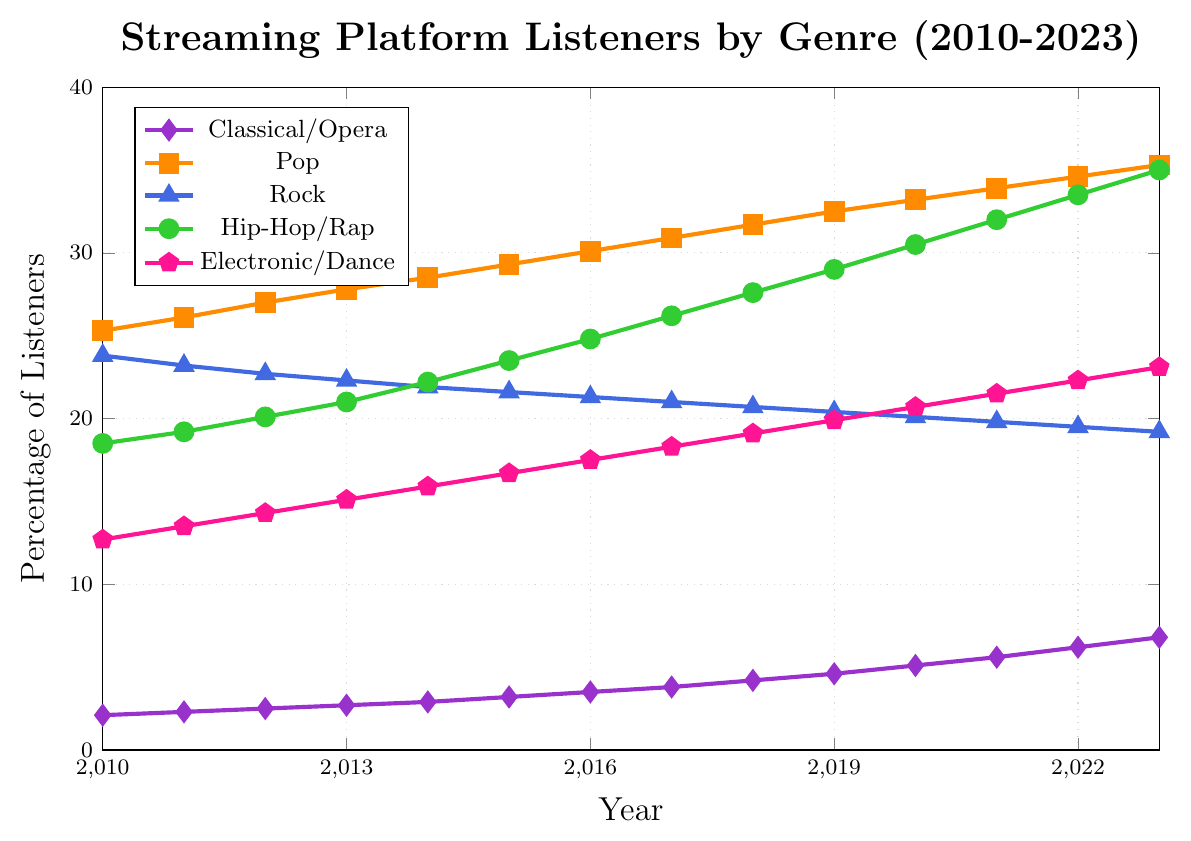What is the percentage increase in Classical/Opera listeners from 2010 to 2023? To calculate the percentage increase, you subtract the starting value (2.1 in 2010) from the ending value (6.8 in 2023), then divide by the starting value and multiply by 100. So, (6.8 - 2.1) / 2.1 * 100 = 223.81%
Answer: 223.81% Which genre had the highest percentage of listeners in 2023? Look at the values for 2023 and find the highest one: Classical/Opera(6.8), Pop(35.3), Rock(19.2), Hip-Hop/Rap(35.0), Electronic/Dance(23.1). Pop has the highest value.
Answer: Pop How many genres had a higher percentage of listeners than Classical/Opera in 2014? In 2014, Classical/Opera had 2.9%. Compare this value to the other genres: Pop(28.5), Rock(21.9), Hip-Hop/Rap(22.2), Electronic/Dance(15.9). All these genres had higher values.
Answer: 4 What is the trend in Rock listeners from 2010 to 2023? Observe the values for Rock from 2010 (23.8) to 2023 (19.2). The values are gradually decreasing over the years.
Answer: Decreasing By how much did Hip-Hop/Rap listeners increase from 2015 to 2020? Subtract the value in 2015 (23.5) from the value in 2020 (30.5). So, 30.5 - 23.5 = 7.0
Answer: 7.0 In which year did Electronic/Dance listeners surpass 20%? Look at the values for Electronic/Dance over the years. In 2020, it reached 20.7%.
Answer: 2020 Which genre experienced the most consistent increase in listeners from 2010 to 2023? Observe the trends of all genres. Classical/Opera shows a consistent increase every year.
Answer: Classical/Opera What is the combined percentage of Pop and Hip-Hop/Rap listeners in 2018? Add the values for Pop (31.7) and Hip-Hop/Rap (27.6) in 2018. So, 31.7 + 27.6 = 59.3
Answer: 59.3 Which genre had the smallest percentage of listeners in 2023? Compare the values for all genres in 2023: Classical/Opera(6.8), Pop(35.3), Rock(19.2), Hip-Hop/Rap(35.0), Electronic/Dance(23.1). Classical/Opera has the smallest value.
Answer: Classical/Opera 